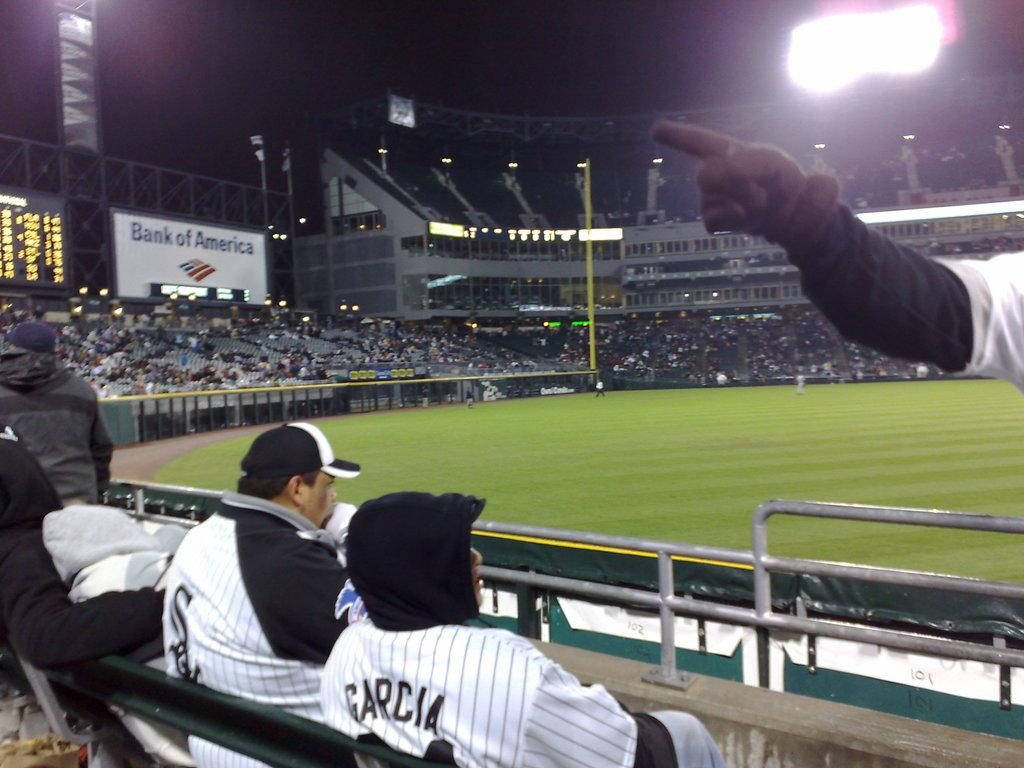<image>
Create a compact narrative representing the image presented. A fan wearing a Garcia jersey sits in the crowd 